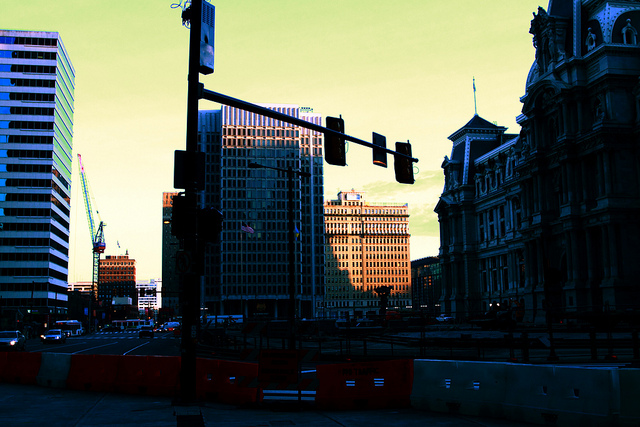Can you describe activities that might be happening in this area during the evening? During the evening, this downtown area likely becomes a hub of activity. It might host a range of after-work events such as happy hours at local bars and eateries. Offices could be letting out, adding to the pedestrian and vehicular traffic. Some streets may even host street performers or pop-up markets, adding a vibrant cultural layer to the nighttime economy here. 